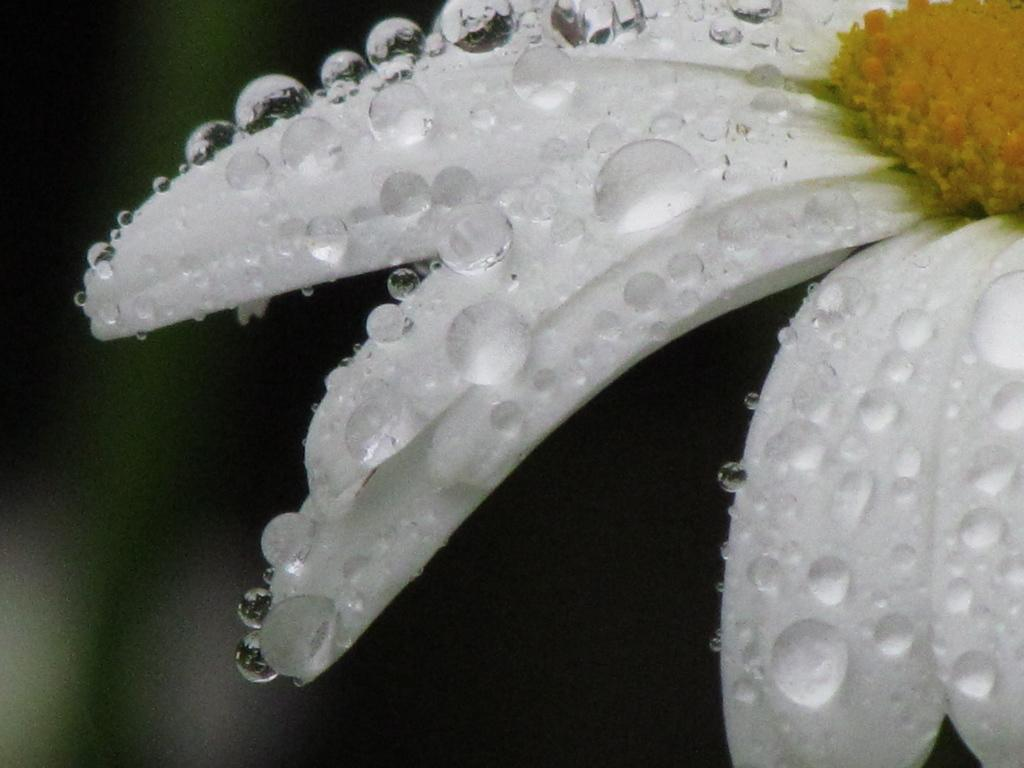What is located on the right side of the image? There is a flower on the right side of the image. Can you describe the flower in more detail? Yes, there are water drops on the petals of the flower. What can be observed about the background of the image? The background of the image is blurry. Where is the map located in the image? There is no map present in the image. What type of tool is being used to dig in the image? There is no digging tool, such as a spade, present in the image. 